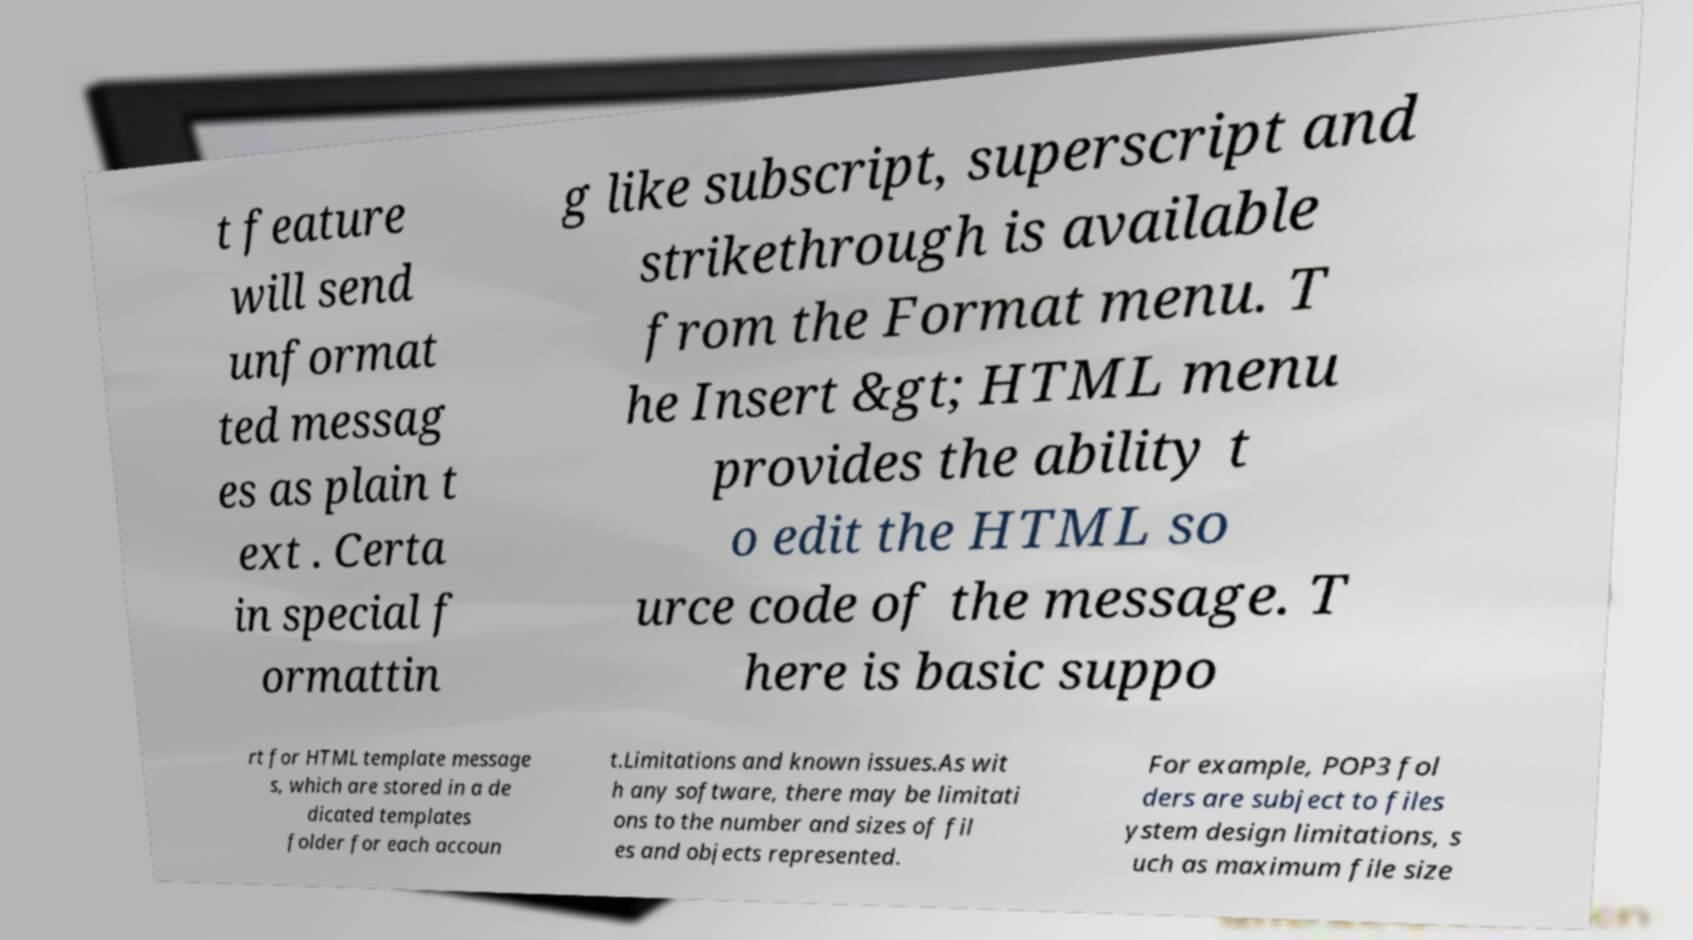There's text embedded in this image that I need extracted. Can you transcribe it verbatim? t feature will send unformat ted messag es as plain t ext . Certa in special f ormattin g like subscript, superscript and strikethrough is available from the Format menu. T he Insert &gt; HTML menu provides the ability t o edit the HTML so urce code of the message. T here is basic suppo rt for HTML template message s, which are stored in a de dicated templates folder for each accoun t.Limitations and known issues.As wit h any software, there may be limitati ons to the number and sizes of fil es and objects represented. For example, POP3 fol ders are subject to files ystem design limitations, s uch as maximum file size 